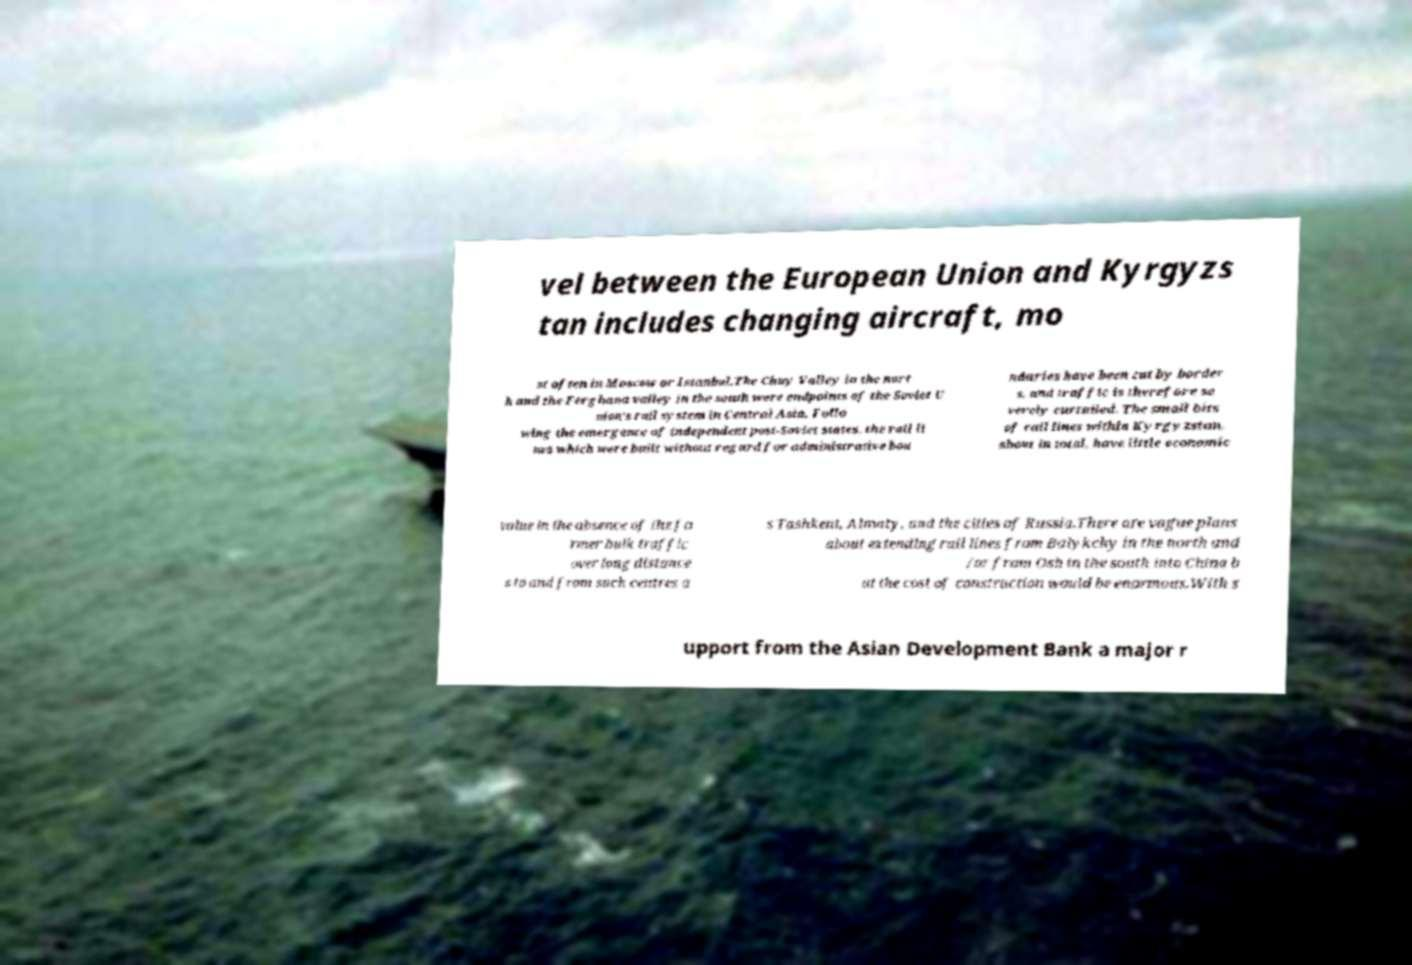For documentation purposes, I need the text within this image transcribed. Could you provide that? vel between the European Union and Kyrgyzs tan includes changing aircraft, mo st often in Moscow or Istanbul.The Chuy Valley in the nort h and the Ferghana valley in the south were endpoints of the Soviet U nion's rail system in Central Asia. Follo wing the emergence of independent post-Soviet states, the rail li nes which were built without regard for administrative bou ndaries have been cut by border s, and traffic is therefore se verely curtailed. The small bits of rail lines within Kyrgyzstan, about in total, have little economic value in the absence of the fo rmer bulk traffic over long distance s to and from such centres a s Tashkent, Almaty, and the cities of Russia.There are vague plans about extending rail lines from Balykchy in the north and /or from Osh in the south into China b ut the cost of construction would be enormous.With s upport from the Asian Development Bank a major r 